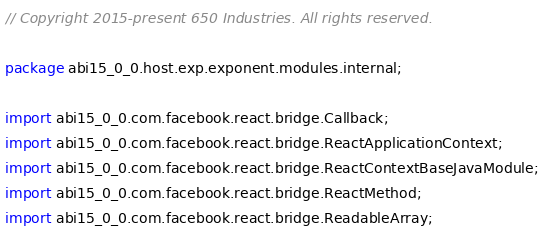<code> <loc_0><loc_0><loc_500><loc_500><_Java_>// Copyright 2015-present 650 Industries. All rights reserved.

package abi15_0_0.host.exp.exponent.modules.internal;

import abi15_0_0.com.facebook.react.bridge.Callback;
import abi15_0_0.com.facebook.react.bridge.ReactApplicationContext;
import abi15_0_0.com.facebook.react.bridge.ReactContextBaseJavaModule;
import abi15_0_0.com.facebook.react.bridge.ReactMethod;
import abi15_0_0.com.facebook.react.bridge.ReadableArray;</code> 